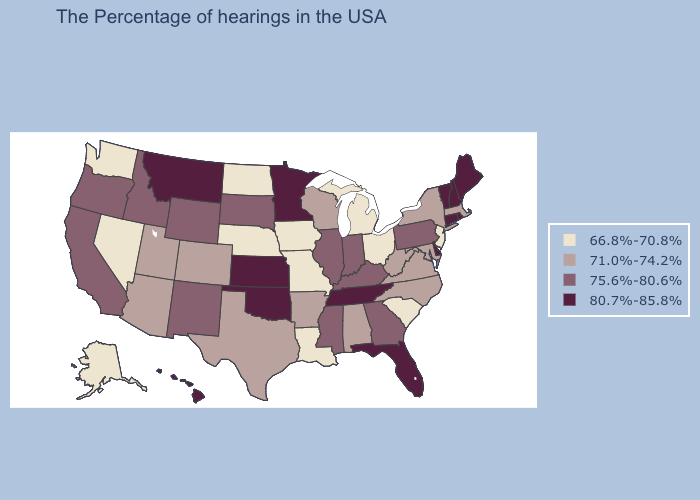What is the value of Montana?
Answer briefly. 80.7%-85.8%. Which states have the highest value in the USA?
Keep it brief. Maine, Rhode Island, New Hampshire, Vermont, Connecticut, Delaware, Florida, Tennessee, Minnesota, Kansas, Oklahoma, Montana, Hawaii. Does Montana have the highest value in the West?
Give a very brief answer. Yes. Name the states that have a value in the range 80.7%-85.8%?
Give a very brief answer. Maine, Rhode Island, New Hampshire, Vermont, Connecticut, Delaware, Florida, Tennessee, Minnesota, Kansas, Oklahoma, Montana, Hawaii. Which states have the lowest value in the South?
Keep it brief. South Carolina, Louisiana. Does South Dakota have the highest value in the USA?
Short answer required. No. Name the states that have a value in the range 75.6%-80.6%?
Be succinct. Pennsylvania, Georgia, Kentucky, Indiana, Illinois, Mississippi, South Dakota, Wyoming, New Mexico, Idaho, California, Oregon. Does Connecticut have the highest value in the USA?
Write a very short answer. Yes. Does Michigan have the lowest value in the USA?
Concise answer only. Yes. What is the value of Iowa?
Quick response, please. 66.8%-70.8%. What is the lowest value in the Northeast?
Short answer required. 66.8%-70.8%. What is the highest value in the USA?
Write a very short answer. 80.7%-85.8%. Name the states that have a value in the range 66.8%-70.8%?
Quick response, please. New Jersey, South Carolina, Ohio, Michigan, Louisiana, Missouri, Iowa, Nebraska, North Dakota, Nevada, Washington, Alaska. Name the states that have a value in the range 75.6%-80.6%?
Give a very brief answer. Pennsylvania, Georgia, Kentucky, Indiana, Illinois, Mississippi, South Dakota, Wyoming, New Mexico, Idaho, California, Oregon. 